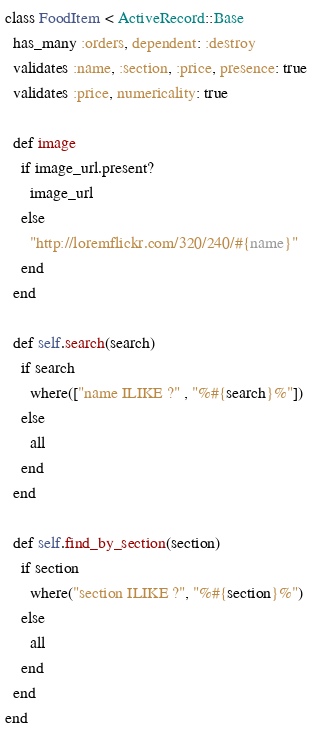<code> <loc_0><loc_0><loc_500><loc_500><_Ruby_>class FoodItem < ActiveRecord::Base
  has_many :orders, dependent: :destroy
  validates :name, :section, :price, presence: true
  validates :price, numericality: true

  def image
    if image_url.present?
      image_url
    else
      "http://loremflickr.com/320/240/#{name}"
    end
  end

  def self.search(search)
    if search
      where(["name ILIKE ?" , "%#{search}%"])
    else
      all
    end
  end

  def self.find_by_section(section)
    if section
      where("section ILIKE ?", "%#{section}%")
    else
      all
    end
  end
end
</code> 